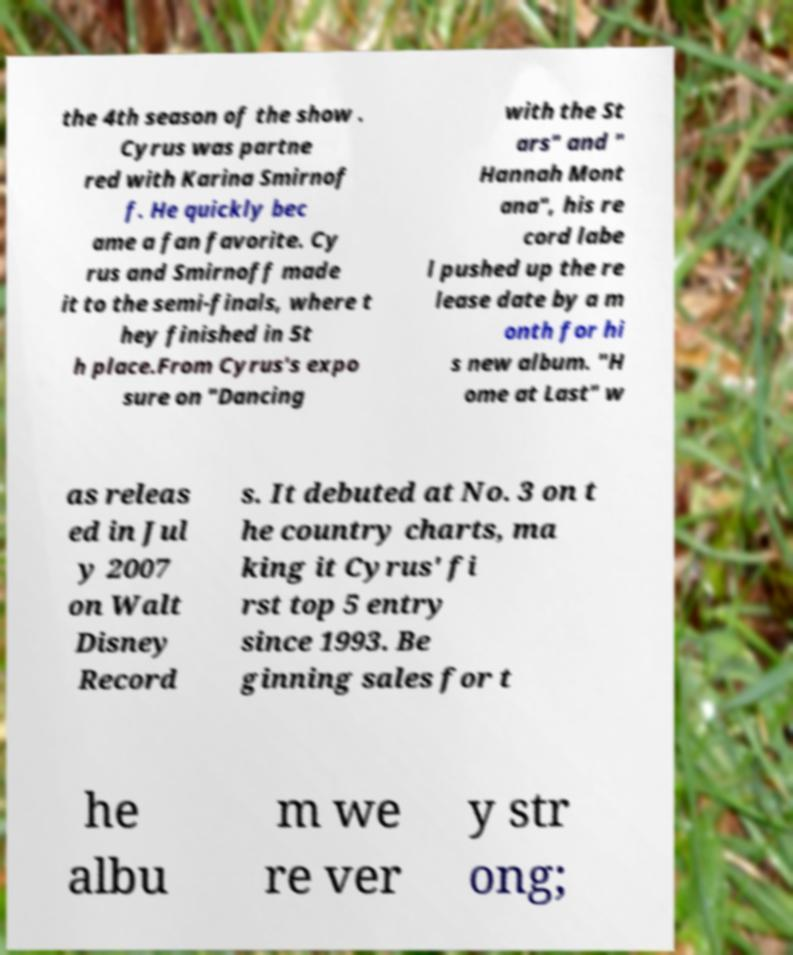Please identify and transcribe the text found in this image. the 4th season of the show . Cyrus was partne red with Karina Smirnof f. He quickly bec ame a fan favorite. Cy rus and Smirnoff made it to the semi-finals, where t hey finished in 5t h place.From Cyrus's expo sure on "Dancing with the St ars" and " Hannah Mont ana", his re cord labe l pushed up the re lease date by a m onth for hi s new album. "H ome at Last" w as releas ed in Jul y 2007 on Walt Disney Record s. It debuted at No. 3 on t he country charts, ma king it Cyrus' fi rst top 5 entry since 1993. Be ginning sales for t he albu m we re ver y str ong; 